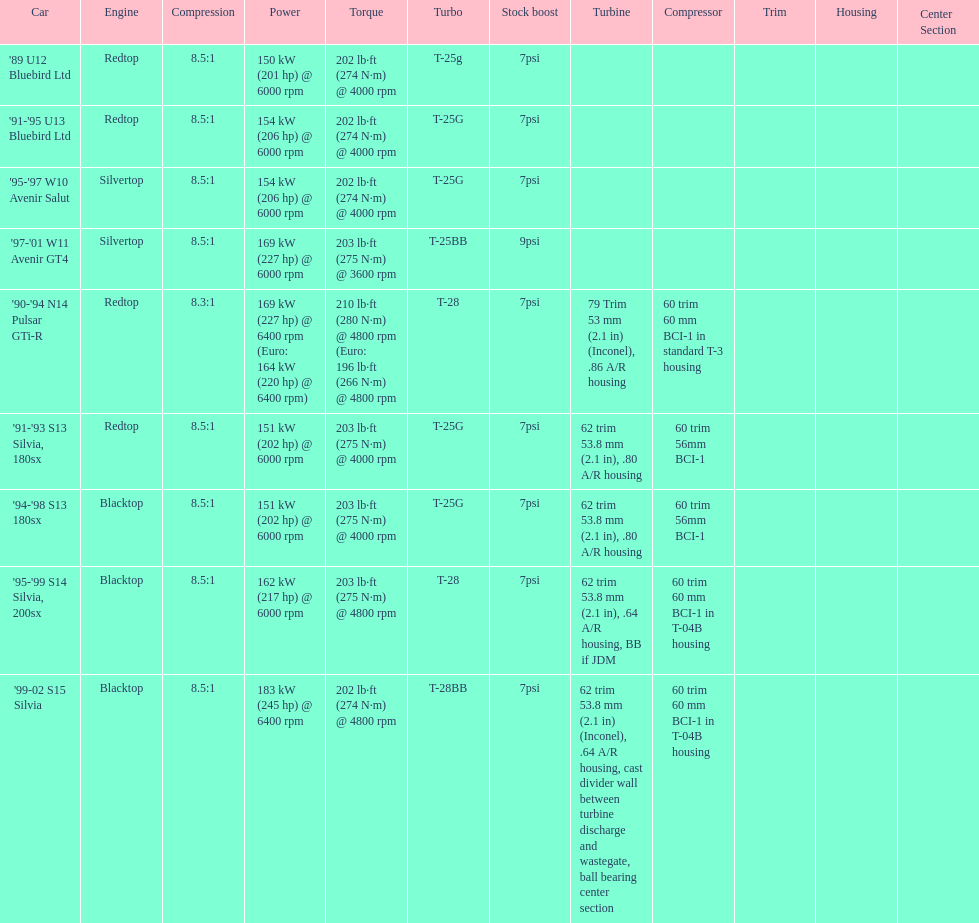Which engines were used after 1999? Silvertop, Blacktop. 